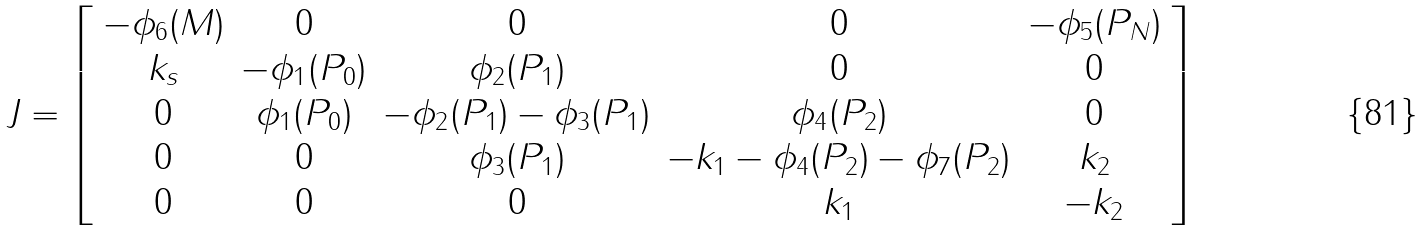<formula> <loc_0><loc_0><loc_500><loc_500>J = \left [ \begin{array} { c c c c c } - \phi _ { 6 } ( M ) & 0 & 0 & 0 & - \phi _ { 5 } ( P _ { N } ) \\ k _ { s } & - \phi _ { 1 } ( P _ { 0 } ) & \phi _ { 2 } ( P _ { 1 } ) & 0 & 0 \\ 0 & \phi _ { 1 } ( P _ { 0 } ) & - \phi _ { 2 } ( P _ { 1 } ) - \phi _ { 3 } ( P _ { 1 } ) & \phi _ { 4 } ( P _ { 2 } ) & 0 \\ 0 & 0 & \phi _ { 3 } ( P _ { 1 } ) & - k _ { 1 } - \phi _ { 4 } ( P _ { 2 } ) - \phi _ { 7 } ( P _ { 2 } ) & k _ { 2 } \\ 0 & 0 & 0 & k _ { 1 } & - k _ { 2 } \end{array} \right ]</formula> 